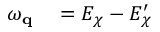Convert formula to latex. <formula><loc_0><loc_0><loc_500><loc_500>\begin{array} { r l } { \omega _ { q } } & = E _ { \chi } - E _ { \chi } ^ { \prime } } \end{array}</formula> 